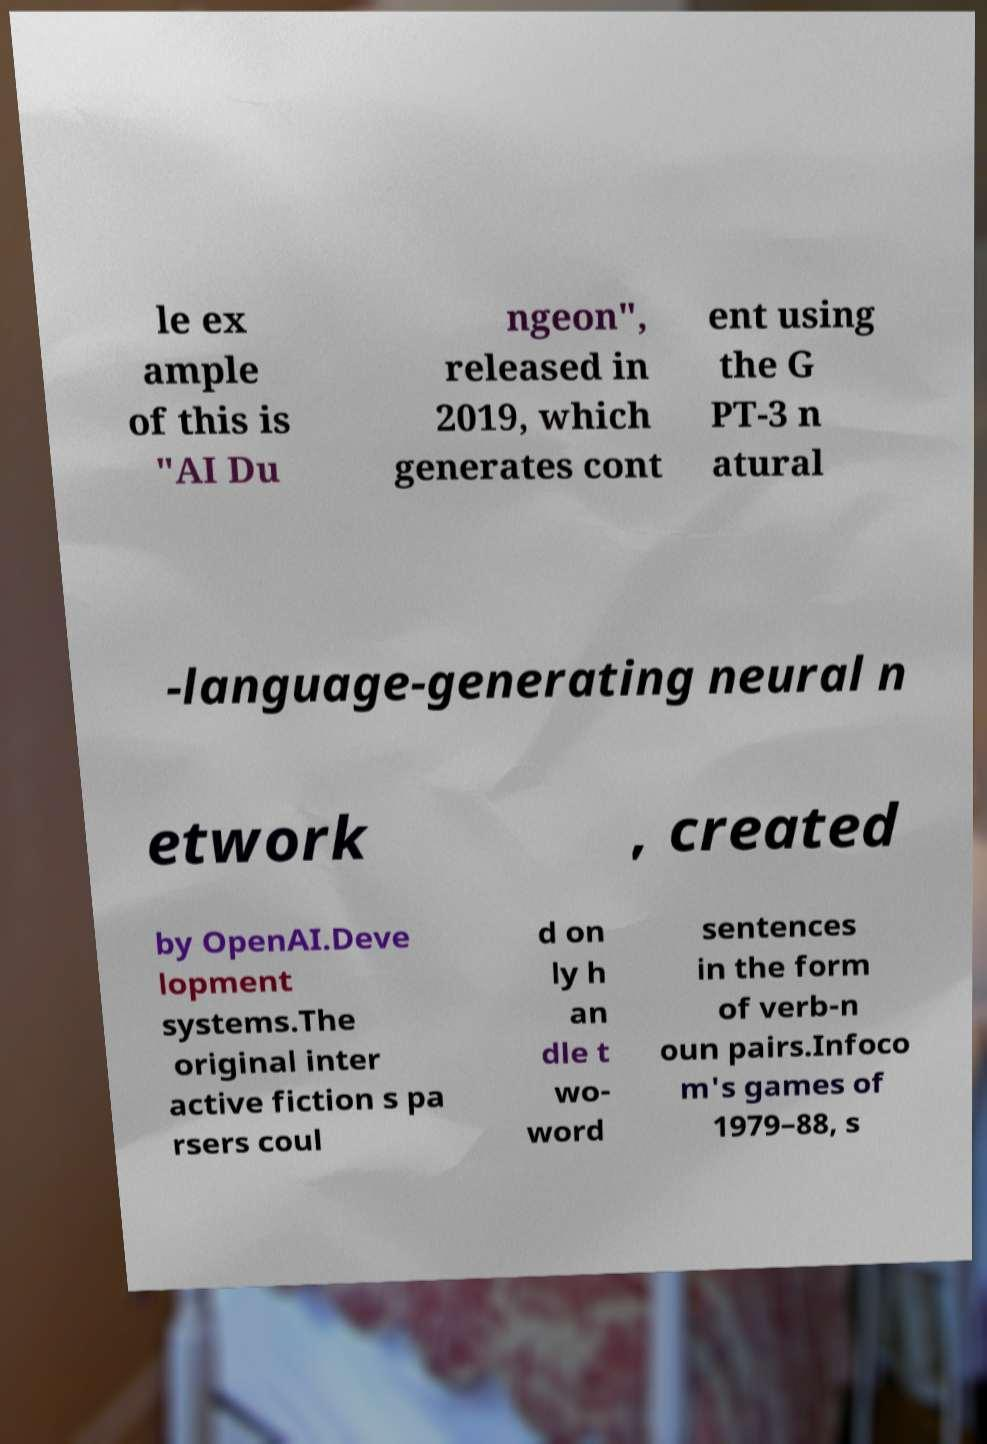Could you assist in decoding the text presented in this image and type it out clearly? le ex ample of this is "AI Du ngeon", released in 2019, which generates cont ent using the G PT-3 n atural -language-generating neural n etwork , created by OpenAI.Deve lopment systems.The original inter active fiction s pa rsers coul d on ly h an dle t wo- word sentences in the form of verb-n oun pairs.Infoco m's games of 1979–88, s 